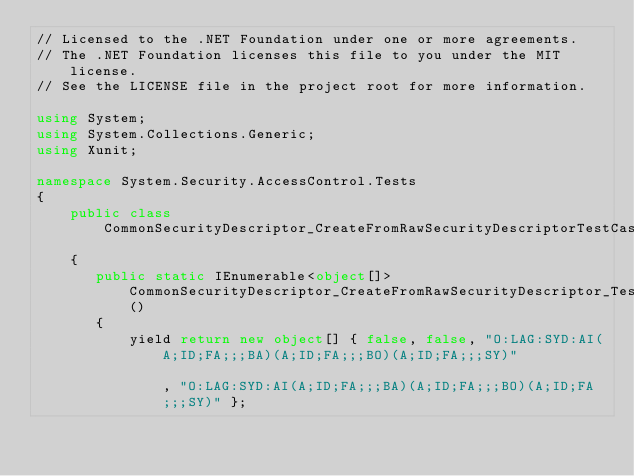Convert code to text. <code><loc_0><loc_0><loc_500><loc_500><_C#_>// Licensed to the .NET Foundation under one or more agreements.
// The .NET Foundation licenses this file to you under the MIT license.
// See the LICENSE file in the project root for more information.

using System;
using System.Collections.Generic;
using Xunit;

namespace System.Security.AccessControl.Tests
{
    public class CommonSecurityDescriptor_CreateFromRawSecurityDescriptorTestCases
    {
       public static IEnumerable<object[]> CommonSecurityDescriptor_CreateFromRawSecurityDescriptor_TestData()
       {
           yield return new object[] { false, false, "O:LAG:SYD:AI(A;ID;FA;;;BA)(A;ID;FA;;;BO)(A;ID;FA;;;SY)"                                                                                                                                                                                                                                                                             , "O:LAG:SYD:AI(A;ID;FA;;;BA)(A;ID;FA;;;BO)(A;ID;FA;;;SY)" };</code> 